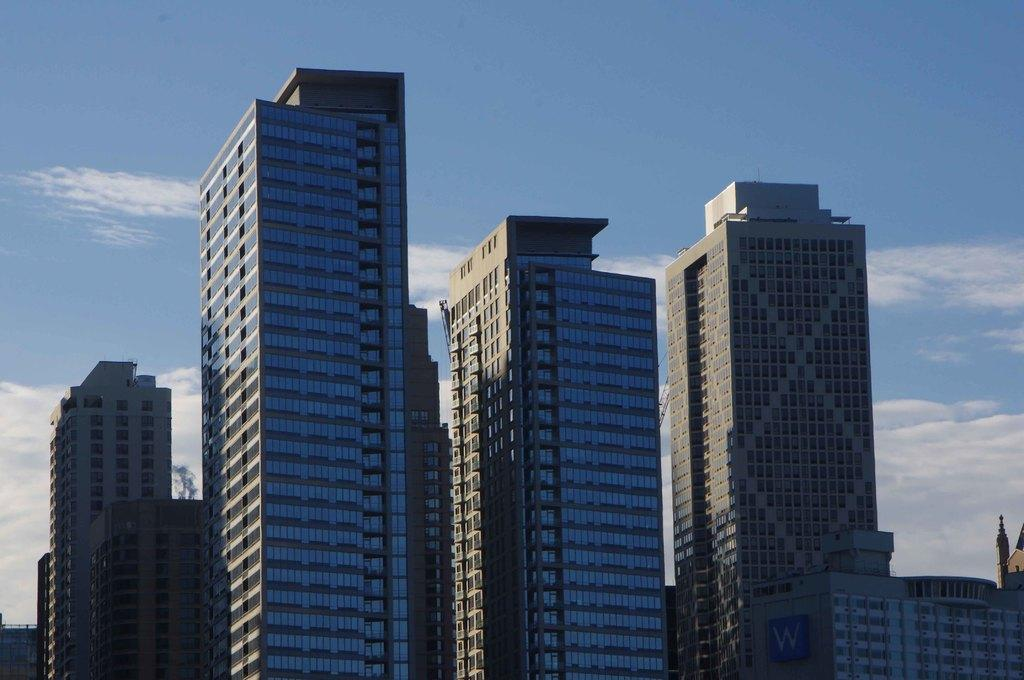What type of structures can be seen in the image? There are buildings in the image. What color is the sky in the image? The sky is blue in the image. Can you find the key that was used to open the door in the image? There is no key present in the image. Is there a receipt visible on the ground in the image? There is no receipt visible in the image. 